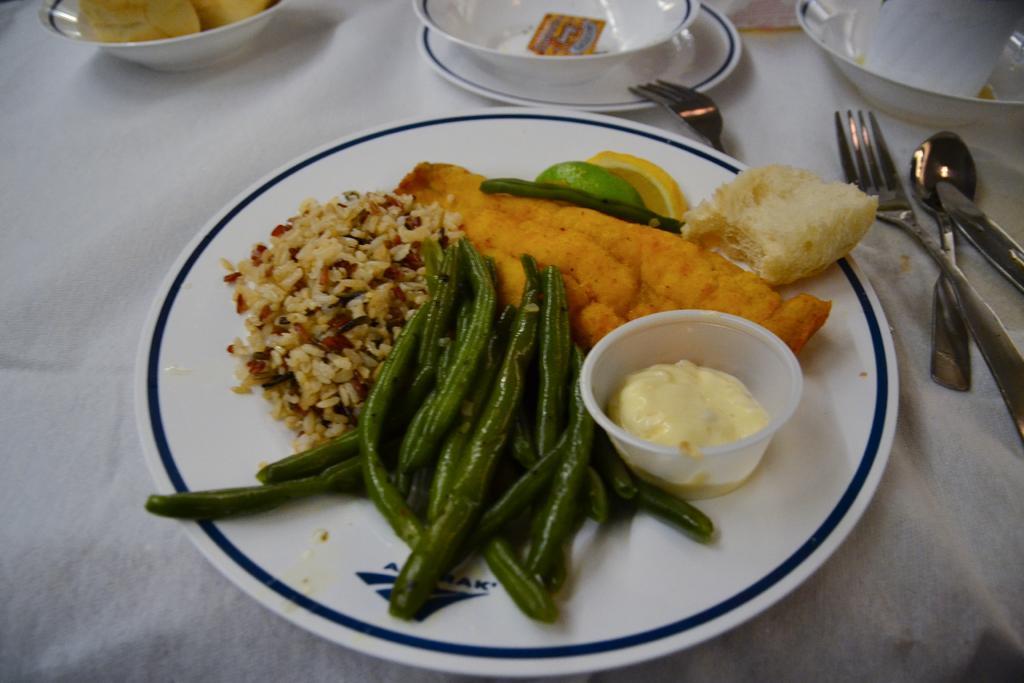Please provide a concise description of this image. In the center of the image there is a plate with food items in it on the table. There are fork spoons and spoons. There are bowls. 